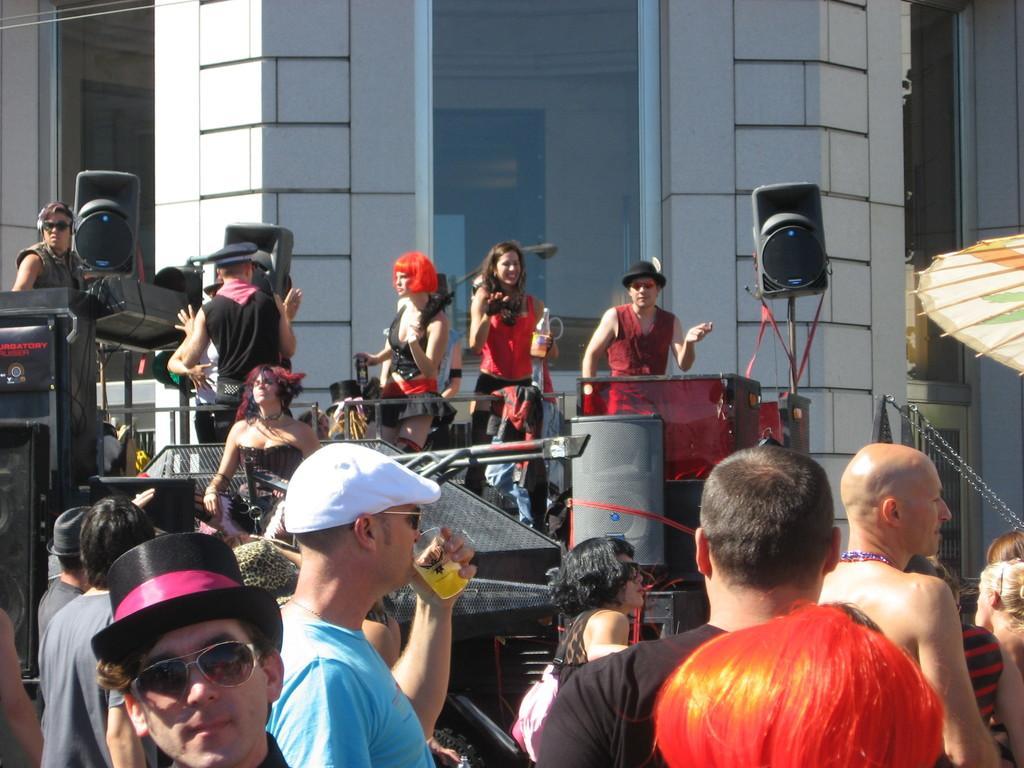How would you summarize this image in a sentence or two? In the foreground I can see a group of people on the road and are holding some objects in their hand and also I can see musical instruments, speakers, tables and some objects. In the background, I can see a building, door, umbrella hut and window. This image is taken may be during a day. 